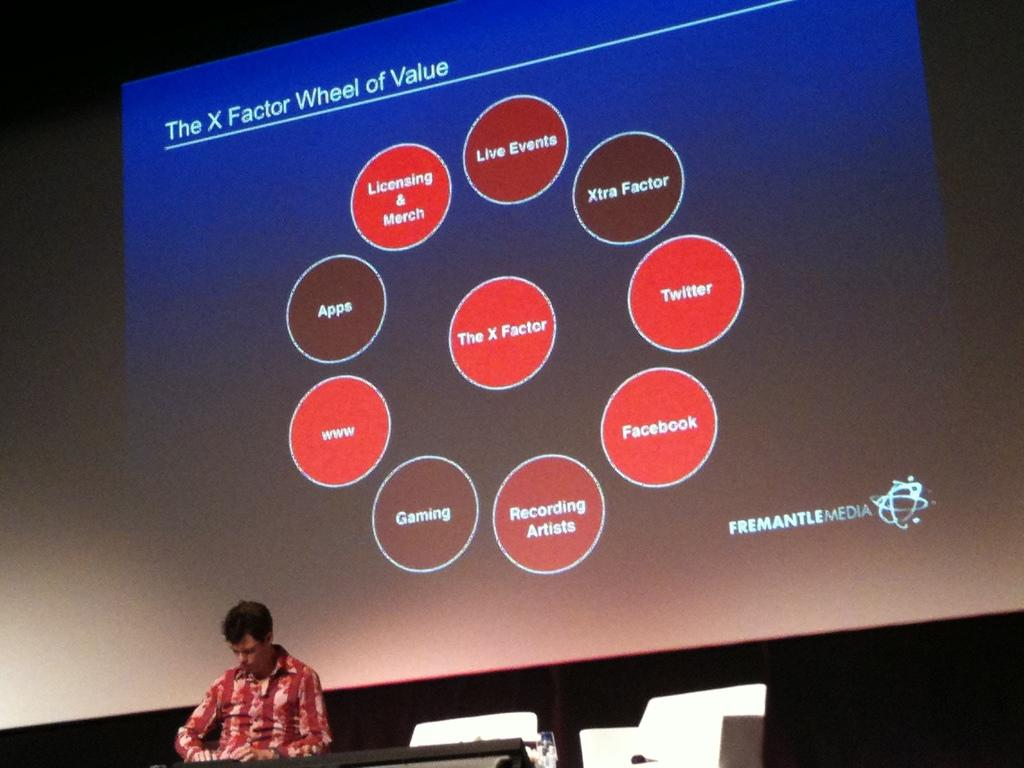Who is present in the image? There is a man in the image. What is the man wearing? The man is wearing a red shirt. What is the man doing in the image? The man is sitting on a chair. What can be seen behind the man? There is a projector screen in the image. What type of insect is crawling on the projector screen in the image? There is no insect present on the projector screen in the image. 